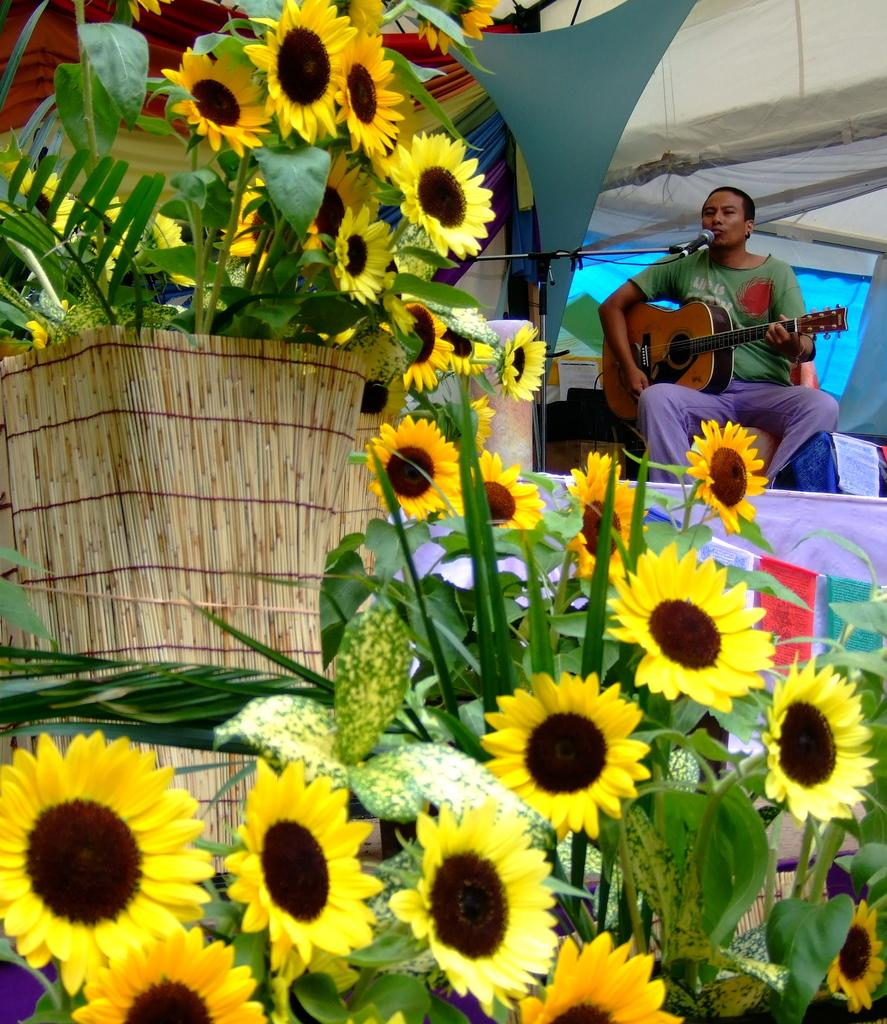What type of flowers are in the image? There are sunflowers in the image. What is the person in the image doing? The person is sitting and playing guitar, and also singing. What object is in front of the person? There is a microphone in front of the person. What color is the background of the image? The background of the image is black. What grade does the person receive for their performance in the image? There is no indication of a performance being graded in the image. How is the cup used in the image? There is no cup present in the image. 